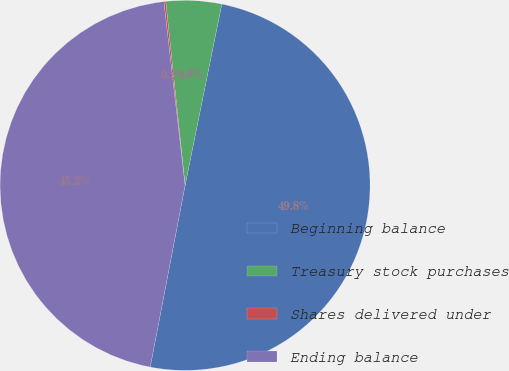Convert chart to OTSL. <chart><loc_0><loc_0><loc_500><loc_500><pie_chart><fcel>Beginning balance<fcel>Treasury stock purchases<fcel>Shares delivered under<fcel>Ending balance<nl><fcel>49.84%<fcel>4.85%<fcel>0.16%<fcel>45.15%<nl></chart> 